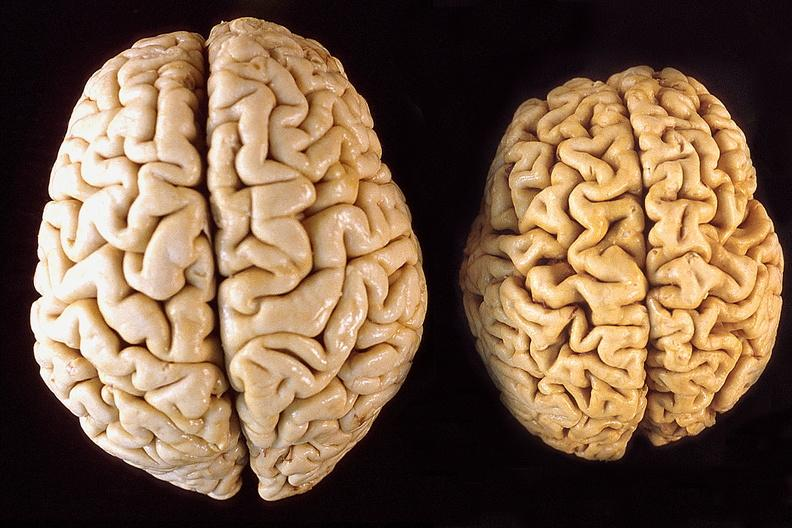s diagnosis present?
Answer the question using a single word or phrase. No 